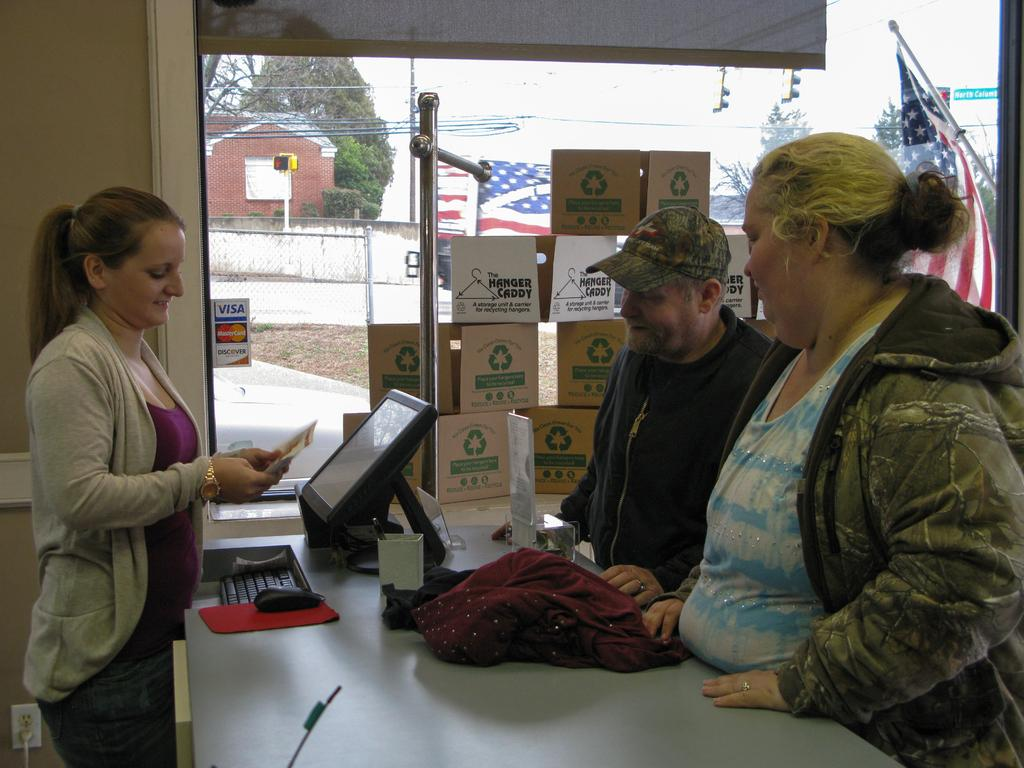What type of structure can be seen in the image? There is a wall in the image. What feature is present in the wall? There is a window in the image. How many people are visible in the image? There are three people standing in the image. What object is on the table in the image? There is a keyboard, a screen, a mouse, and a cloth on the table. What nation is represented by the flag on the table in the image? There is no flag present on the table in the image. What question is being asked by the person standing on the left side of the image? There is no indication of a question being asked in the image. 